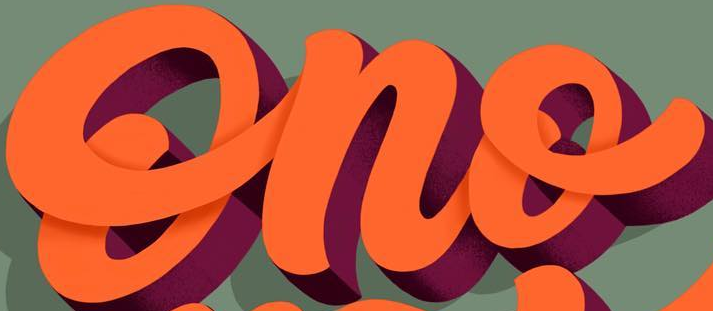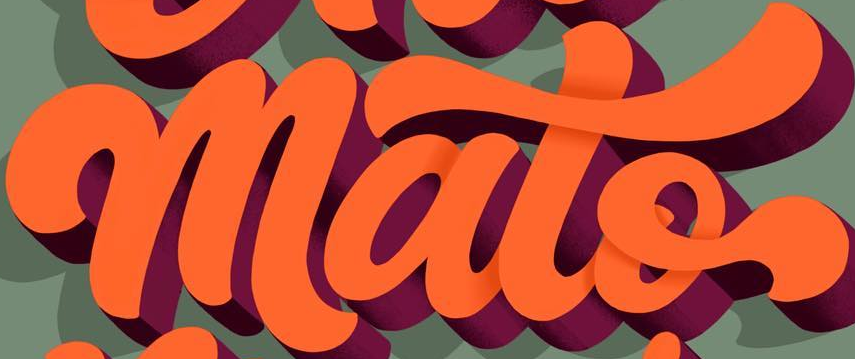Identify the words shown in these images in order, separated by a semicolon. Ono; mato 